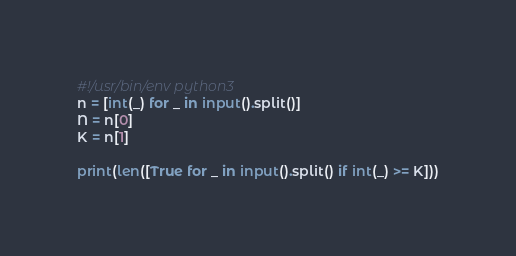Convert code to text. <code><loc_0><loc_0><loc_500><loc_500><_Python_>#!/usr/bin/env python3
n = [int(_) for _ in input().split()]
N = n[0]
K = n[1]

print(len([True for _ in input().split() if int(_) >= K]))
</code> 